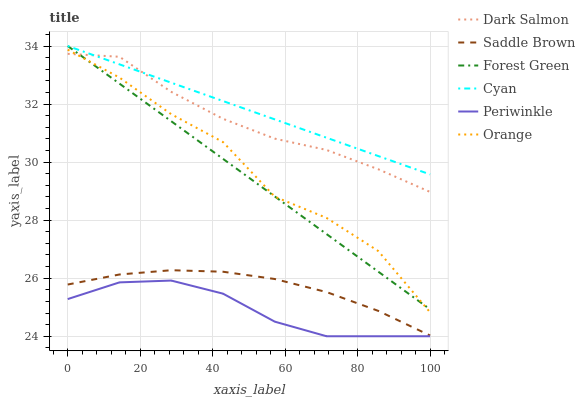Does Periwinkle have the minimum area under the curve?
Answer yes or no. Yes. Does Cyan have the maximum area under the curve?
Answer yes or no. Yes. Does Forest Green have the minimum area under the curve?
Answer yes or no. No. Does Forest Green have the maximum area under the curve?
Answer yes or no. No. Is Forest Green the smoothest?
Answer yes or no. Yes. Is Orange the roughest?
Answer yes or no. Yes. Is Periwinkle the smoothest?
Answer yes or no. No. Is Periwinkle the roughest?
Answer yes or no. No. Does Forest Green have the lowest value?
Answer yes or no. No. Does Periwinkle have the highest value?
Answer yes or no. No. Is Saddle Brown less than Orange?
Answer yes or no. Yes. Is Orange greater than Saddle Brown?
Answer yes or no. Yes. Does Saddle Brown intersect Orange?
Answer yes or no. No. 